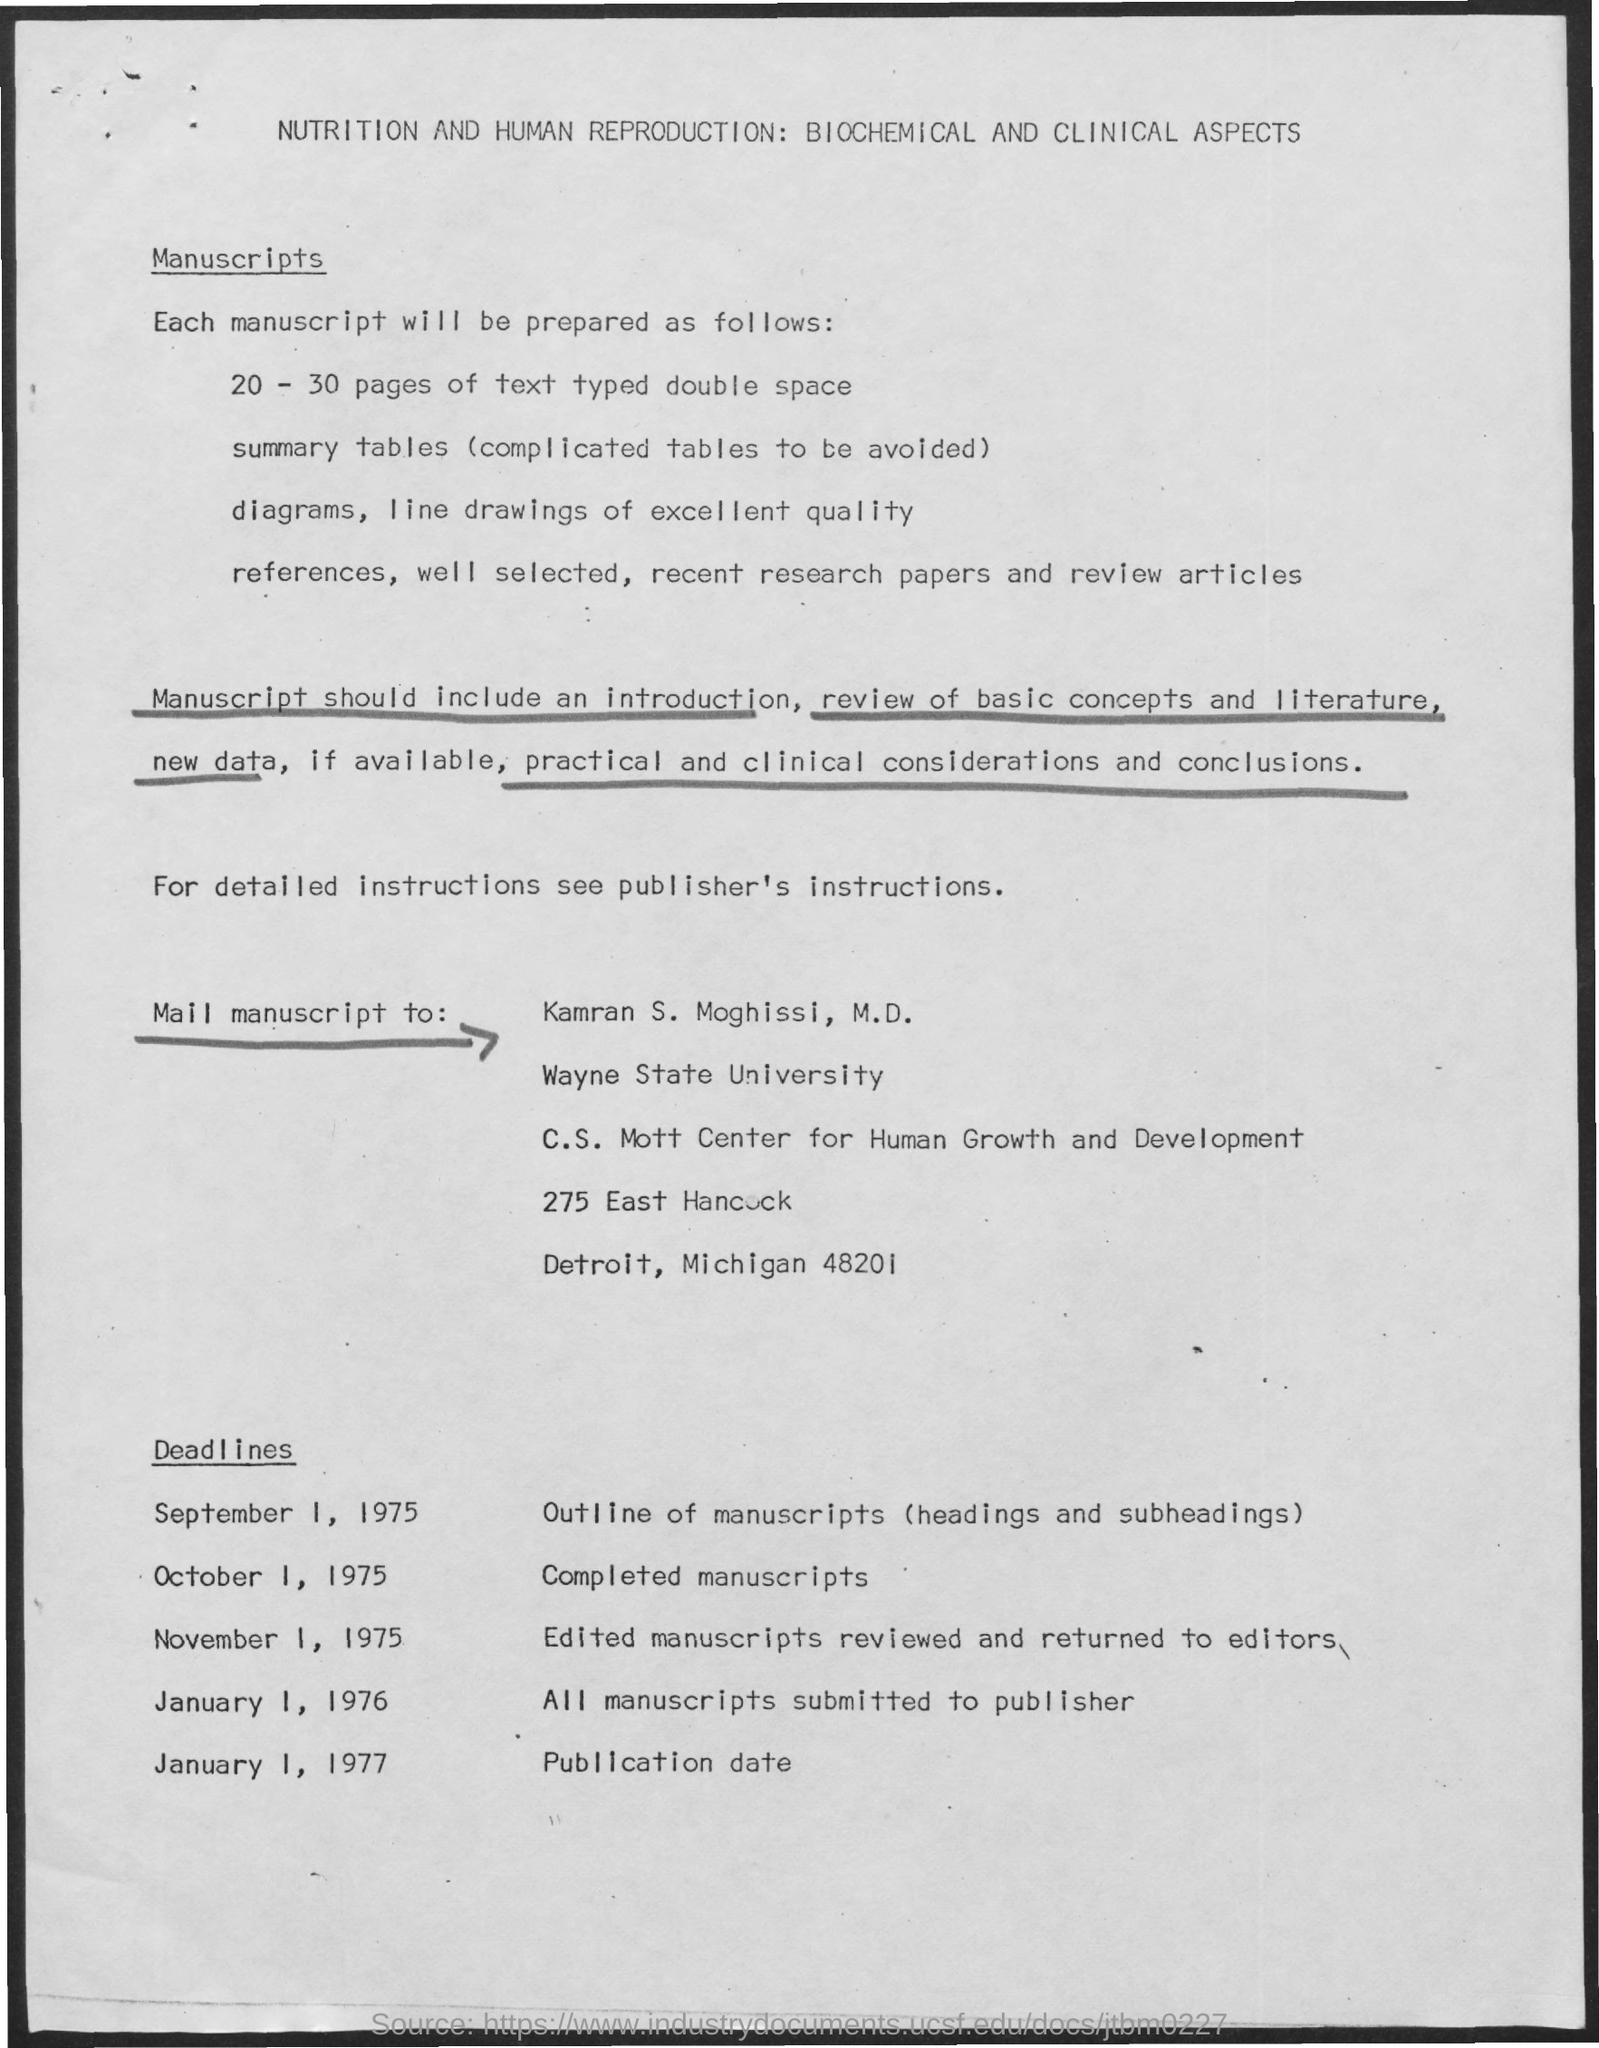Give some essential details in this illustration. The deadline for completed manuscripts is October 1, 1975. The addressee of the manuscript should be Kamran S. Moghissi, M.D. The deadline for all manuscripts submitted to the publisher is January 1, 1976. The deadline for outlines of manuscripts, including headings and subheadings, is September 1, 1975. Kamran S. Moghissi, a medical doctor who is affiliated with Wayne State University, has a background in that institution. 